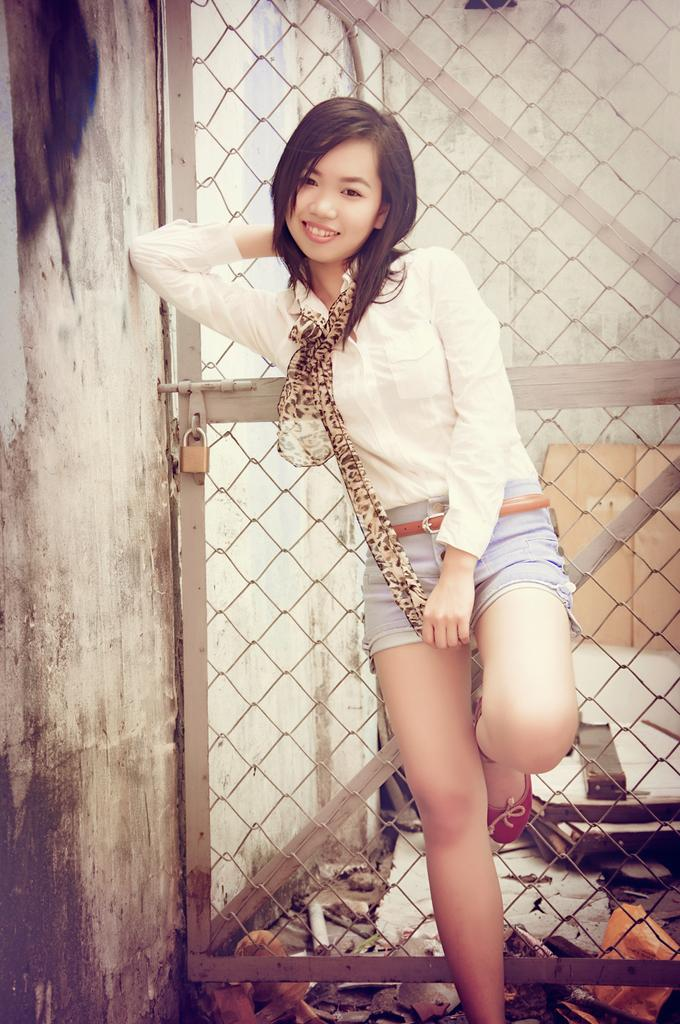What is the woman doing in the image? The woman is standing beside a wall in the image. What can be seen near the wall in the image? There is a metal gate with a lock visible in the image. What other objects are present in the image? There are objects present in the image, but their specific nature is not mentioned in the facts. What is on the floor in the image? There is a board on the floor in the image. How does the woman's grip on the wall change throughout the image? The image does not show any change in the woman's grip on the wall, as it is a static image. 